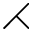Convert formula to latex. <formula><loc_0><loc_0><loc_500><loc_500>\right t h r e e t i m e s</formula> 